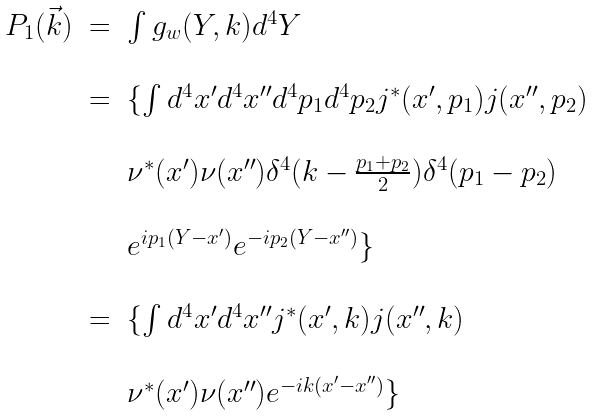<formula> <loc_0><loc_0><loc_500><loc_500>\begin{array} { l c l } P _ { 1 } ( \vec { k } ) & = & \int g _ { w } ( Y , k ) d ^ { 4 } Y \\ & & \\ & = & \{ \int d ^ { 4 } x ^ { \prime } d ^ { 4 } x ^ { \prime \prime } d ^ { 4 } p _ { 1 } d ^ { 4 } p _ { 2 } j ^ { * } ( x ^ { \prime } , p _ { 1 } ) j ( x ^ { \prime \prime } , p _ { 2 } ) \\ & & \\ & & \nu ^ { * } ( x ^ { \prime } ) \nu ( x ^ { \prime \prime } ) \delta ^ { 4 } ( k - \frac { p _ { 1 } + p _ { 2 } } { 2 } ) \delta ^ { 4 } ( p _ { 1 } - p _ { 2 } ) \\ & & \\ & & e ^ { i p _ { 1 } ( Y - x ^ { \prime } ) } e ^ { - i p _ { 2 } ( Y - x ^ { \prime \prime } ) } \} \\ & & \\ & = & \{ \int d ^ { 4 } x ^ { \prime } d ^ { 4 } x ^ { \prime \prime } j ^ { * } ( x ^ { \prime } , k ) j ( x ^ { \prime \prime } , k ) \\ & & \\ & & \nu ^ { * } ( x ^ { \prime } ) \nu ( x ^ { \prime \prime } ) e ^ { - i k ( x ^ { \prime } - x ^ { \prime \prime } ) } \} \\ \end{array}</formula> 